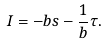Convert formula to latex. <formula><loc_0><loc_0><loc_500><loc_500>I = - b s - \frac { 1 } { b } \tau .</formula> 